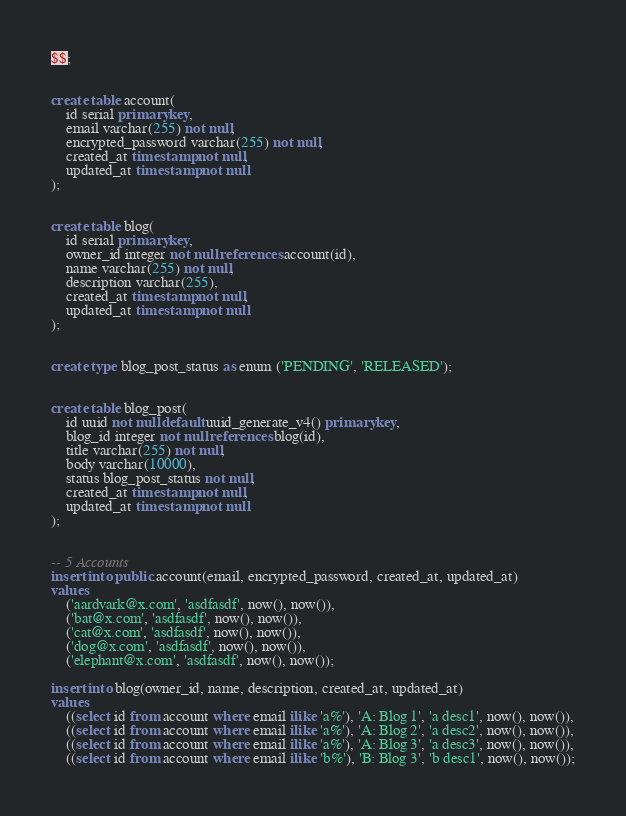<code> <loc_0><loc_0><loc_500><loc_500><_SQL_>$$;


create table account(
    id serial primary key,
    email varchar(255) not null,
    encrypted_password varchar(255) not null,
    created_at timestamp not null,
    updated_at timestamp not null
);


create table blog(
    id serial primary key,
    owner_id integer not null references account(id),
    name varchar(255) not null,
    description varchar(255),
    created_at timestamp not null,
    updated_at timestamp not null
);


create type blog_post_status as enum ('PENDING', 'RELEASED');


create table blog_post(
    id uuid not null default uuid_generate_v4() primary key,
    blog_id integer not null references blog(id),
    title varchar(255) not null,
    body varchar(10000),
    status blog_post_status not null,
    created_at timestamp not null,
    updated_at timestamp not null
);


-- 5 Accounts
insert into public.account(email, encrypted_password, created_at, updated_at)
values
    ('aardvark@x.com', 'asdfasdf', now(), now()),
    ('bat@x.com', 'asdfasdf', now(), now()),
    ('cat@x.com', 'asdfasdf', now(), now()),
    ('dog@x.com', 'asdfasdf', now(), now()),
    ('elephant@x.com', 'asdfasdf', now(), now());

insert into blog(owner_id, name, description, created_at, updated_at)
values
    ((select id from account where email ilike 'a%'), 'A: Blog 1', 'a desc1', now(), now()),
    ((select id from account where email ilike 'a%'), 'A: Blog 2', 'a desc2', now(), now()),
    ((select id from account where email ilike 'a%'), 'A: Blog 3', 'a desc3', now(), now()),
    ((select id from account where email ilike 'b%'), 'B: Blog 3', 'b desc1', now(), now());
</code> 